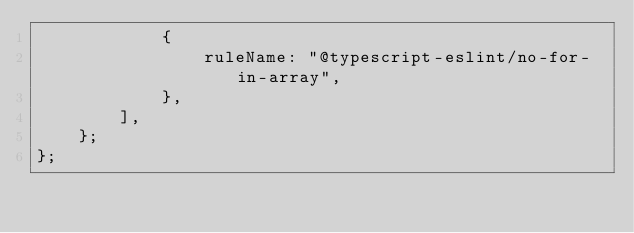<code> <loc_0><loc_0><loc_500><loc_500><_TypeScript_>            {
                ruleName: "@typescript-eslint/no-for-in-array",
            },
        ],
    };
};
</code> 